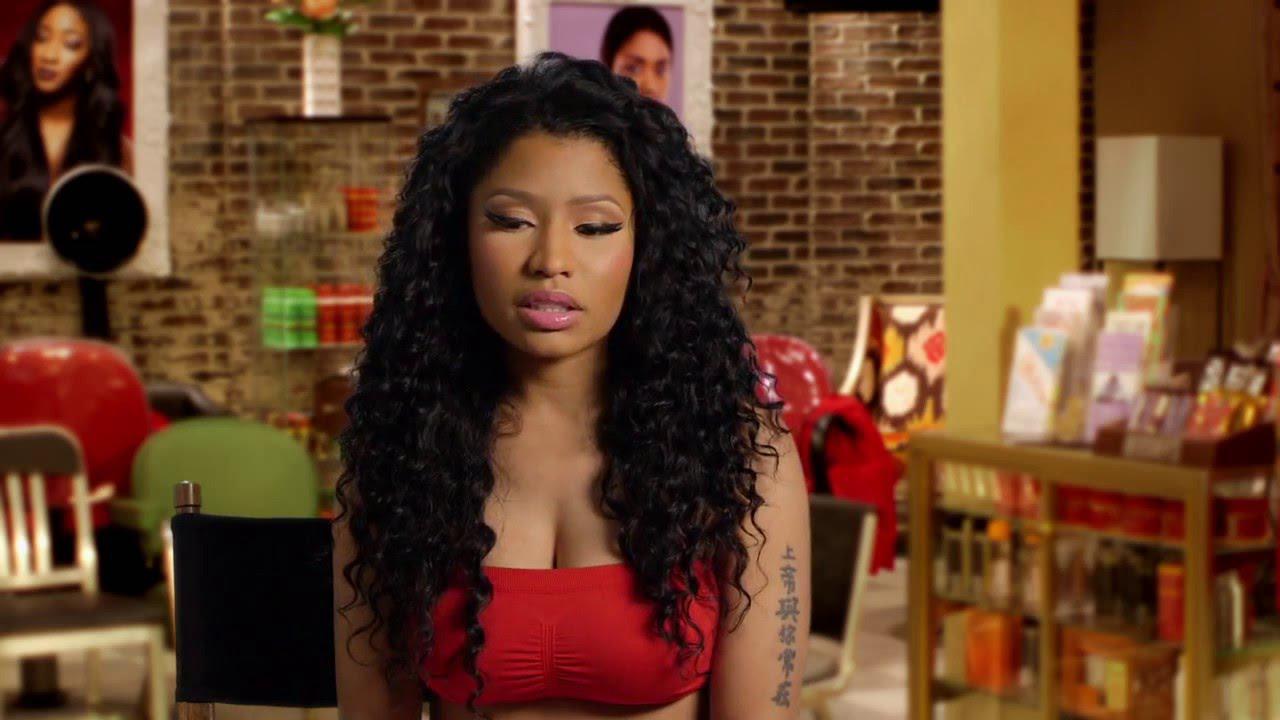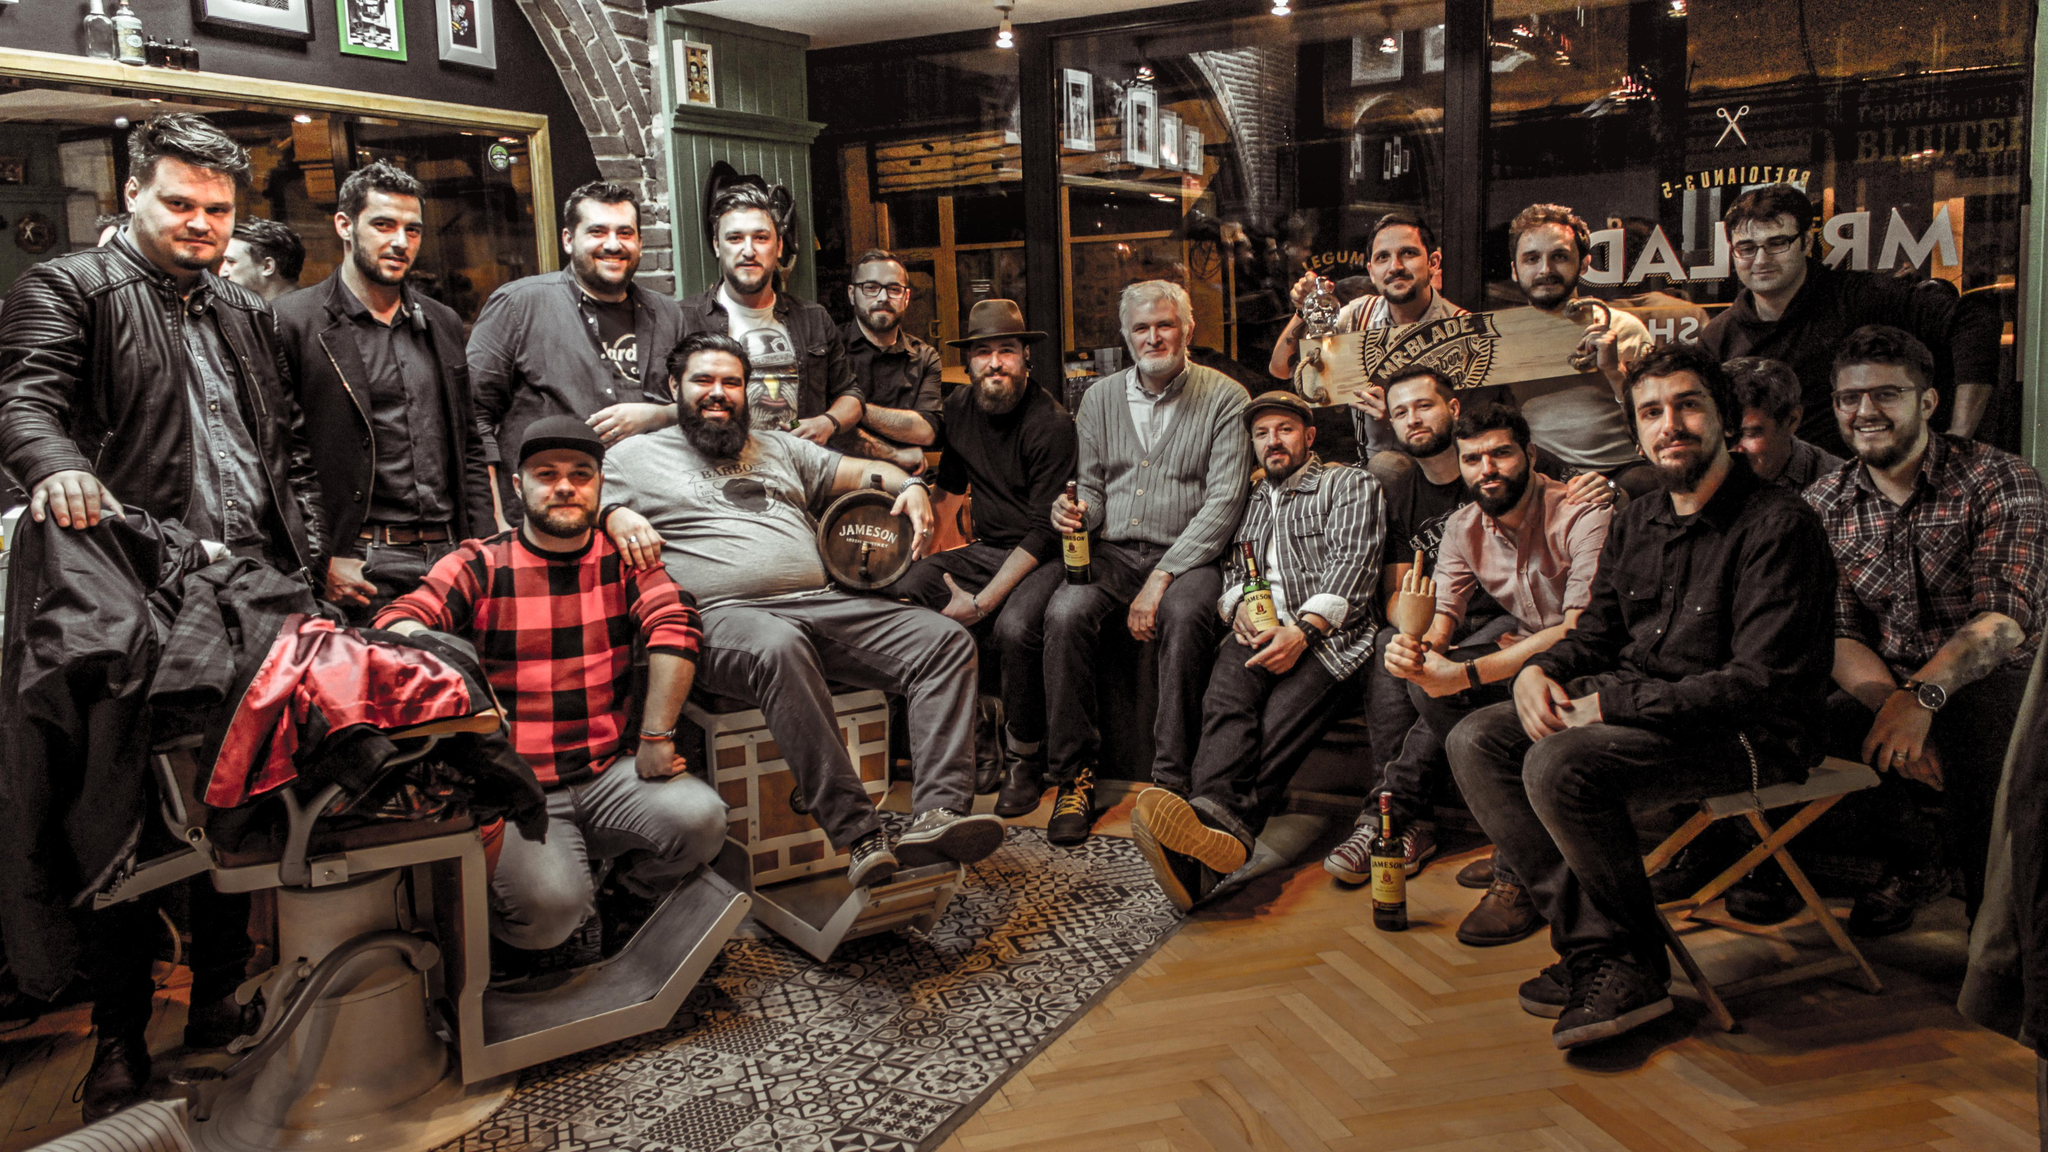The first image is the image on the left, the second image is the image on the right. Examine the images to the left and right. Is the description "Nikki  Ménage is dressed in gold and black with a single short blond hair and woman in the background." accurate? Answer yes or no. No. The first image is the image on the left, the second image is the image on the right. Analyze the images presented: Is the assertion "Nikki Minaj is NOT in the image on the right." valid? Answer yes or no. Yes. The first image is the image on the left, the second image is the image on the right. For the images displayed, is the sentence "There is a woman in red in one of the images." factually correct? Answer yes or no. Yes. The first image is the image on the left, the second image is the image on the right. For the images displayed, is the sentence "Only men are present in one of the barbershop images." factually correct? Answer yes or no. Yes. 